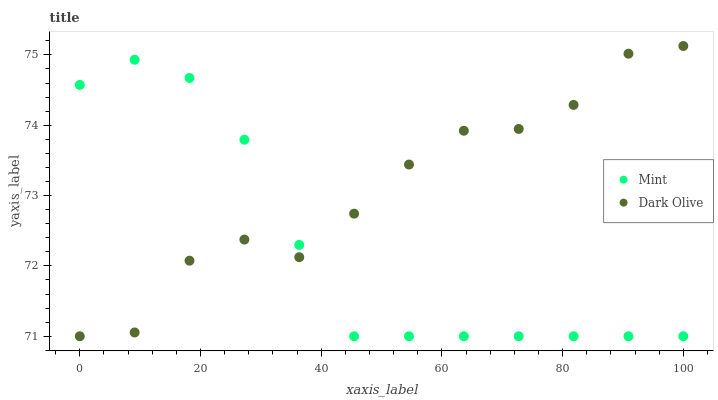Does Mint have the minimum area under the curve?
Answer yes or no. Yes. Does Dark Olive have the maximum area under the curve?
Answer yes or no. Yes. Does Mint have the maximum area under the curve?
Answer yes or no. No. Is Mint the smoothest?
Answer yes or no. Yes. Is Dark Olive the roughest?
Answer yes or no. Yes. Is Mint the roughest?
Answer yes or no. No. Does Dark Olive have the lowest value?
Answer yes or no. Yes. Does Dark Olive have the highest value?
Answer yes or no. Yes. Does Mint have the highest value?
Answer yes or no. No. Does Dark Olive intersect Mint?
Answer yes or no. Yes. Is Dark Olive less than Mint?
Answer yes or no. No. Is Dark Olive greater than Mint?
Answer yes or no. No. 